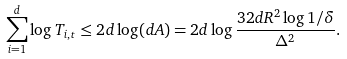<formula> <loc_0><loc_0><loc_500><loc_500>\sum _ { i = 1 } ^ { d } \log T _ { i , t } & \leq 2 d \log ( d A ) = 2 d \log \frac { 3 2 d R ^ { 2 } \log 1 / \delta } { \Delta ^ { 2 } } .</formula> 